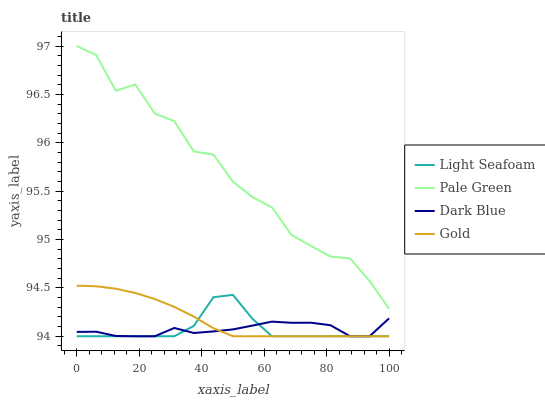Does Dark Blue have the minimum area under the curve?
Answer yes or no. Yes. Does Pale Green have the maximum area under the curve?
Answer yes or no. Yes. Does Light Seafoam have the minimum area under the curve?
Answer yes or no. No. Does Light Seafoam have the maximum area under the curve?
Answer yes or no. No. Is Gold the smoothest?
Answer yes or no. Yes. Is Pale Green the roughest?
Answer yes or no. Yes. Is Light Seafoam the smoothest?
Answer yes or no. No. Is Light Seafoam the roughest?
Answer yes or no. No. Does Light Seafoam have the lowest value?
Answer yes or no. Yes. Does Pale Green have the highest value?
Answer yes or no. Yes. Does Light Seafoam have the highest value?
Answer yes or no. No. Is Light Seafoam less than Pale Green?
Answer yes or no. Yes. Is Pale Green greater than Dark Blue?
Answer yes or no. Yes. Does Gold intersect Light Seafoam?
Answer yes or no. Yes. Is Gold less than Light Seafoam?
Answer yes or no. No. Is Gold greater than Light Seafoam?
Answer yes or no. No. Does Light Seafoam intersect Pale Green?
Answer yes or no. No. 